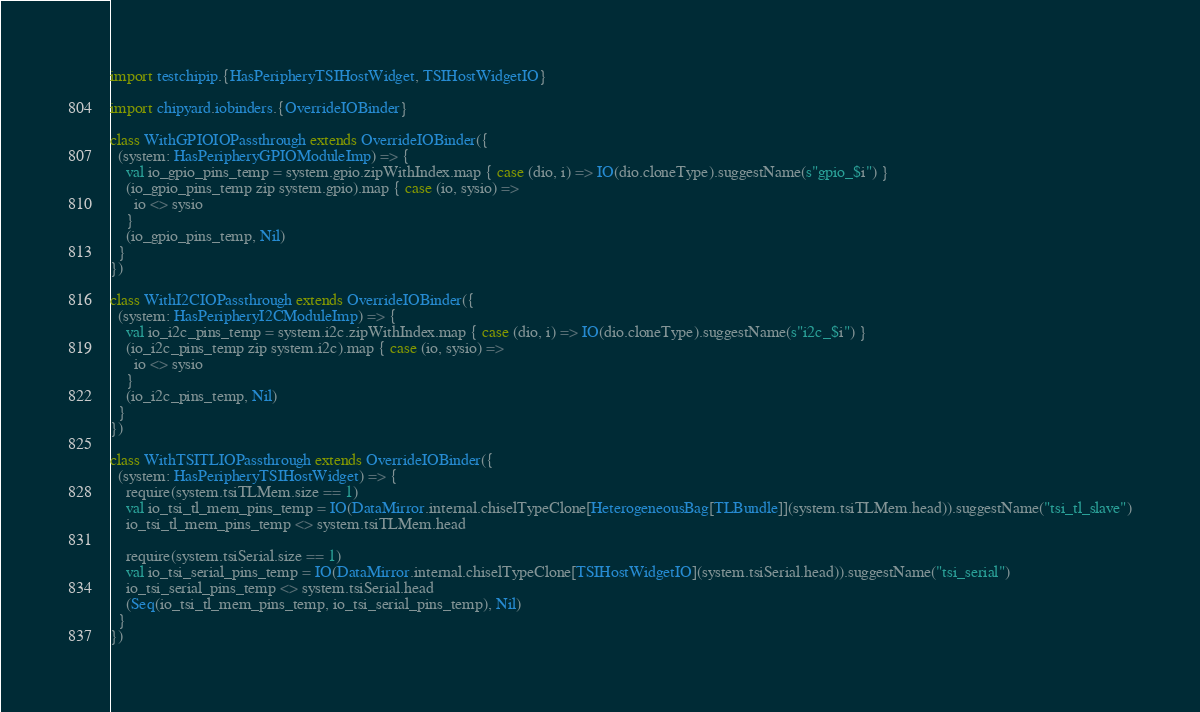<code> <loc_0><loc_0><loc_500><loc_500><_Scala_>import testchipip.{HasPeripheryTSIHostWidget, TSIHostWidgetIO}

import chipyard.iobinders.{OverrideIOBinder}

class WithGPIOIOPassthrough extends OverrideIOBinder({
  (system: HasPeripheryGPIOModuleImp) => {
    val io_gpio_pins_temp = system.gpio.zipWithIndex.map { case (dio, i) => IO(dio.cloneType).suggestName(s"gpio_$i") }
    (io_gpio_pins_temp zip system.gpio).map { case (io, sysio) =>
      io <> sysio
    }
    (io_gpio_pins_temp, Nil)
  }
})

class WithI2CIOPassthrough extends OverrideIOBinder({
  (system: HasPeripheryI2CModuleImp) => {
    val io_i2c_pins_temp = system.i2c.zipWithIndex.map { case (dio, i) => IO(dio.cloneType).suggestName(s"i2c_$i") }
    (io_i2c_pins_temp zip system.i2c).map { case (io, sysio) =>
      io <> sysio
    }
    (io_i2c_pins_temp, Nil)
  }
})

class WithTSITLIOPassthrough extends OverrideIOBinder({
  (system: HasPeripheryTSIHostWidget) => {
    require(system.tsiTLMem.size == 1)
    val io_tsi_tl_mem_pins_temp = IO(DataMirror.internal.chiselTypeClone[HeterogeneousBag[TLBundle]](system.tsiTLMem.head)).suggestName("tsi_tl_slave")
    io_tsi_tl_mem_pins_temp <> system.tsiTLMem.head

    require(system.tsiSerial.size == 1)
    val io_tsi_serial_pins_temp = IO(DataMirror.internal.chiselTypeClone[TSIHostWidgetIO](system.tsiSerial.head)).suggestName("tsi_serial")
    io_tsi_serial_pins_temp <> system.tsiSerial.head
    (Seq(io_tsi_tl_mem_pins_temp, io_tsi_serial_pins_temp), Nil)
  }
})
</code> 